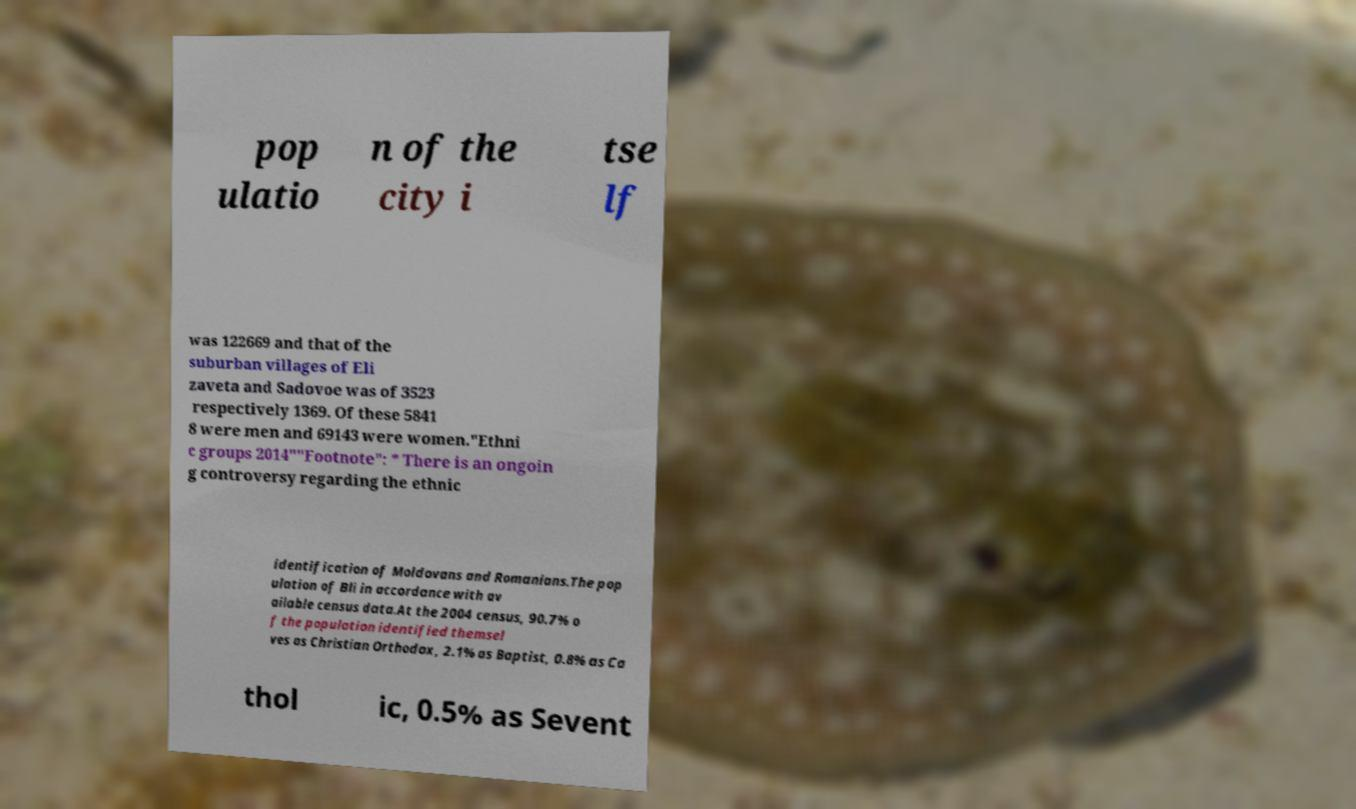Could you extract and type out the text from this image? pop ulatio n of the city i tse lf was 122669 and that of the suburban villages of Eli zaveta and Sadovoe was of 3523 respectively 1369. Of these 5841 8 were men and 69143 were women."Ethni c groups 2014""Footnote": * There is an ongoin g controversy regarding the ethnic identification of Moldovans and Romanians.The pop ulation of Bli in accordance with av ailable census data.At the 2004 census, 90.7% o f the population identified themsel ves as Christian Orthodox, 2.1% as Baptist, 0.8% as Ca thol ic, 0.5% as Sevent 